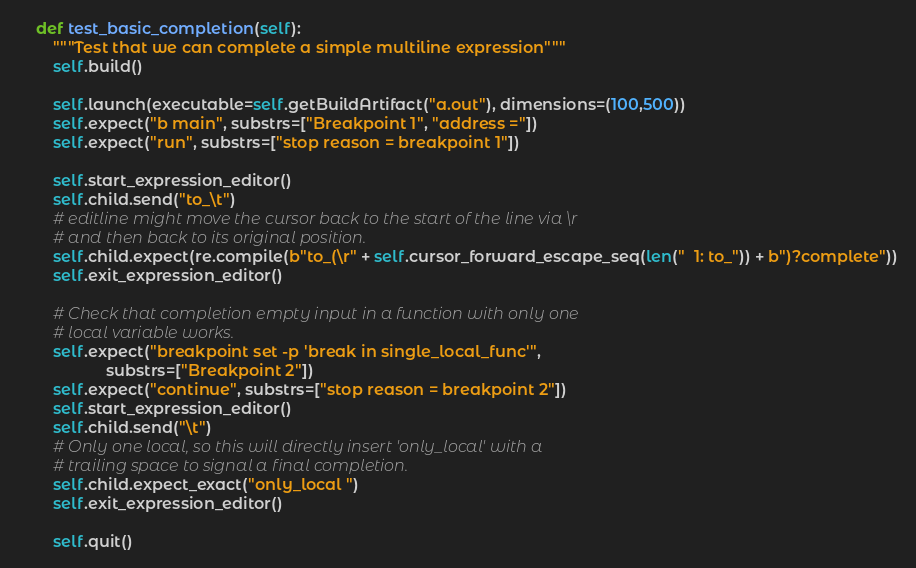Convert code to text. <code><loc_0><loc_0><loc_500><loc_500><_Python_>    def test_basic_completion(self):
        """Test that we can complete a simple multiline expression"""
        self.build()

        self.launch(executable=self.getBuildArtifact("a.out"), dimensions=(100,500))
        self.expect("b main", substrs=["Breakpoint 1", "address ="])
        self.expect("run", substrs=["stop reason = breakpoint 1"])

        self.start_expression_editor()
        self.child.send("to_\t")
        # editline might move the cursor back to the start of the line via \r
        # and then back to its original position.
        self.child.expect(re.compile(b"to_(\r" + self.cursor_forward_escape_seq(len("  1: to_")) + b")?complete"))
        self.exit_expression_editor()

        # Check that completion empty input in a function with only one
        # local variable works.
        self.expect("breakpoint set -p 'break in single_local_func'",
                    substrs=["Breakpoint 2"])
        self.expect("continue", substrs=["stop reason = breakpoint 2"])
        self.start_expression_editor()
        self.child.send("\t")
        # Only one local, so this will directly insert 'only_local' with a
        # trailing space to signal a final completion.
        self.child.expect_exact("only_local ")
        self.exit_expression_editor()

        self.quit()
</code> 